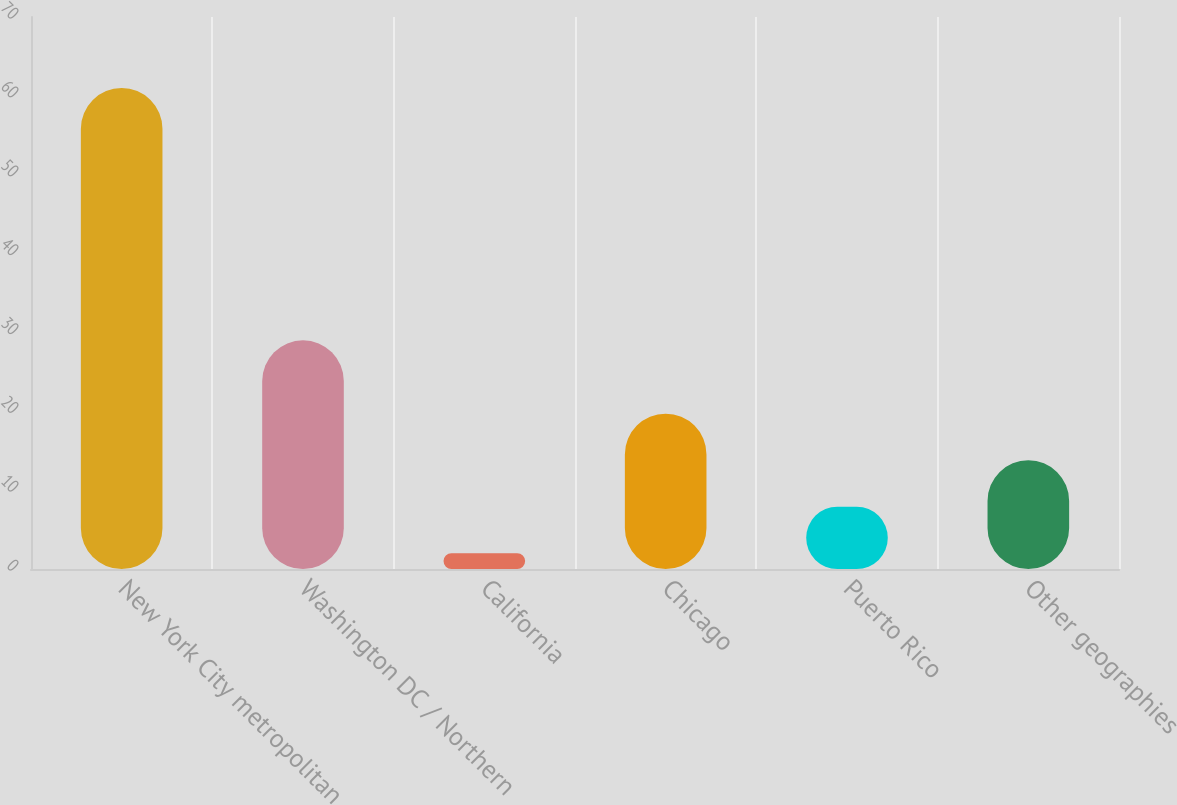Convert chart. <chart><loc_0><loc_0><loc_500><loc_500><bar_chart><fcel>New York City metropolitan<fcel>Washington DC / Northern<fcel>California<fcel>Chicago<fcel>Puerto Rico<fcel>Other geographies<nl><fcel>61<fcel>29<fcel>2<fcel>19.7<fcel>7.9<fcel>13.8<nl></chart> 